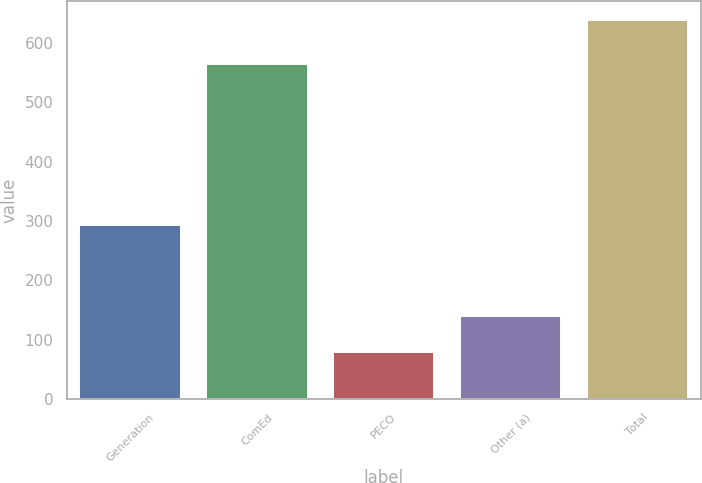Convert chart to OTSL. <chart><loc_0><loc_0><loc_500><loc_500><bar_chart><fcel>Generation<fcel>ComEd<fcel>PECO<fcel>Other (a)<fcel>Total<nl><fcel>294<fcel>564<fcel>79<fcel>140<fcel>639<nl></chart> 